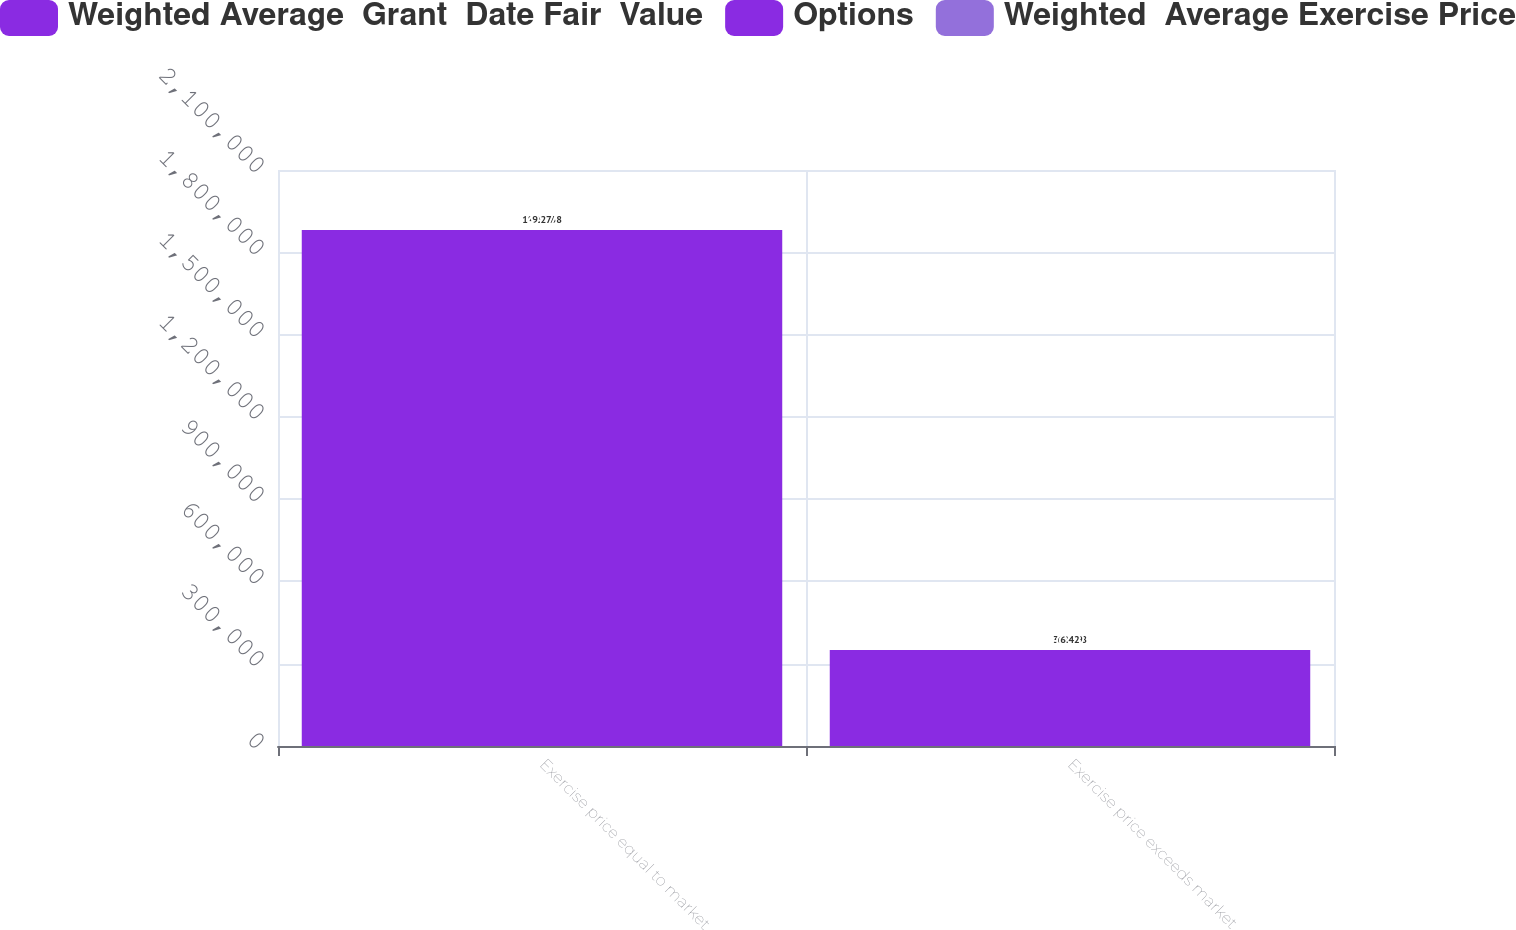Convert chart to OTSL. <chart><loc_0><loc_0><loc_500><loc_500><stacked_bar_chart><ecel><fcel>Exercise price equal to market<fcel>Exercise price exceeds market<nl><fcel>Weighted Average  Grant  Date Fair  Value<fcel>1.88116e+06<fcel>350188<nl><fcel>Options<fcel>40.97<fcel>62.79<nl><fcel>Weighted  Average Exercise Price<fcel>9.27<fcel>6.42<nl></chart> 